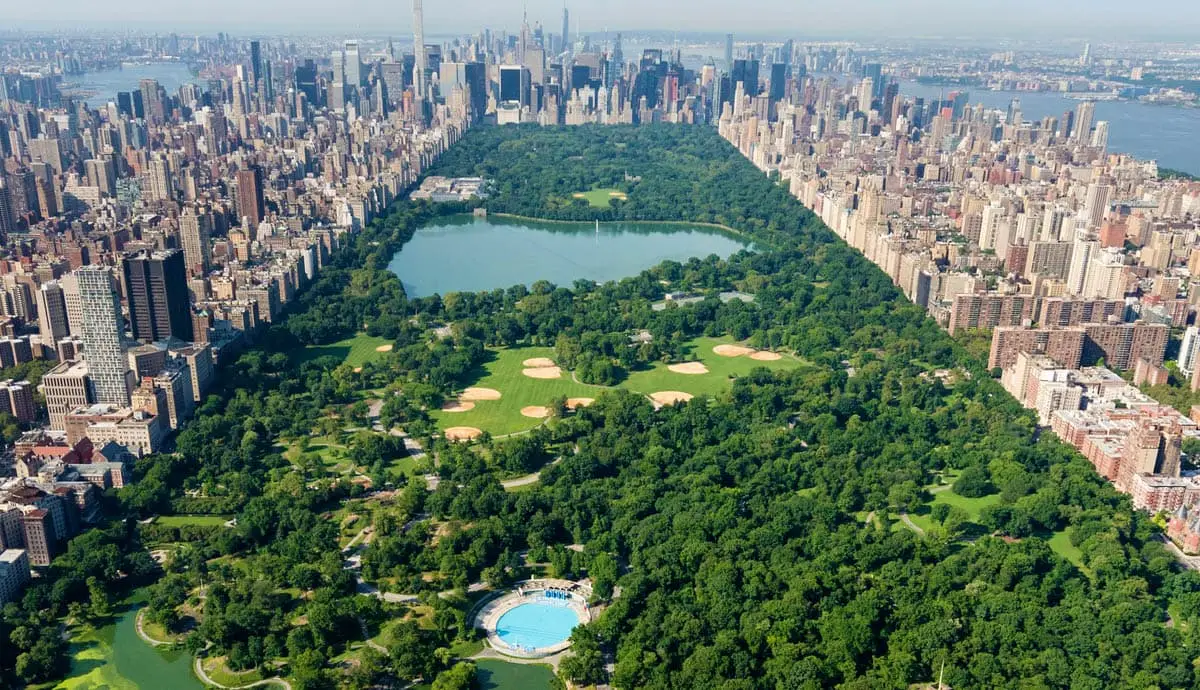Can you tell me more about the activities that happen in Central Park? Central Park is a hub of activities throughout the year, catering to all ages and interests. It features walking and cycling paths, boating, horse-carriage rides, and remote-controlled sailboat racing at landmarks like the Conservatory Water. The park is also a cultural venue, hosting performances at the Delacorte Theater and concerts at the Great Lawn. Additionally, sports enthusiasts enjoy the baseball fields, soccer fields, and the numerous playgrounds scattered throughout the park. In the winter, the Wollman Rink offers ice skating, making the park a year-round attraction. What historical importance does Central Park hold? Central Park is historically significant as one of the earliest public parks in the United States, established in 1858. It was designed by Frederick Law Olmsted and Calvert Vaux, who envisioned a grand natural sanctuary for all New Yorkers. The park has witnessed countless historical events and cultural shifts, becoming a symbol of community and greenery preserved within a metropolitan setting. Its design inspired the creation of urban parks nationwide, pioneering the concept of landscaped public spaces within cities. 